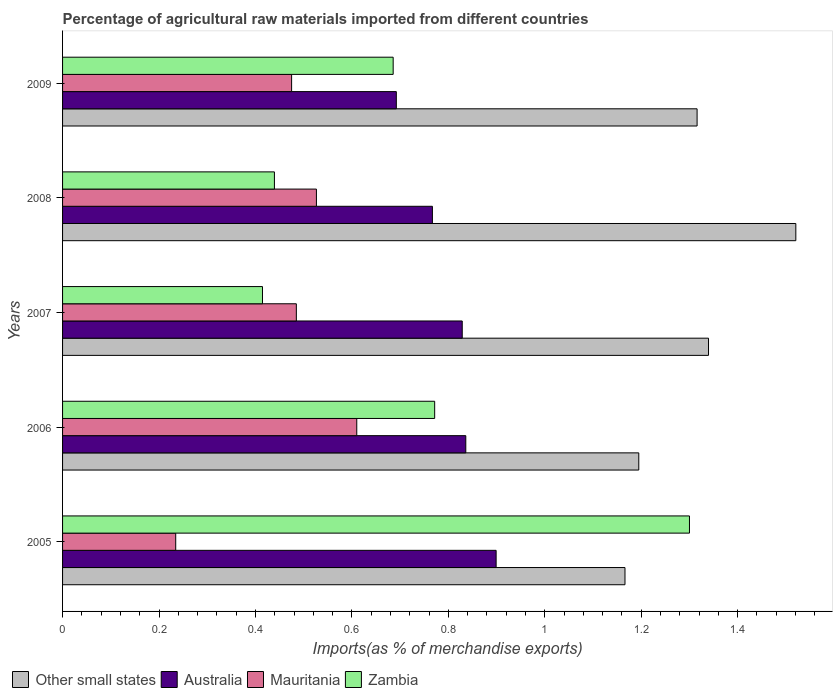How many bars are there on the 2nd tick from the bottom?
Give a very brief answer. 4. What is the label of the 3rd group of bars from the top?
Offer a very short reply. 2007. What is the percentage of imports to different countries in Mauritania in 2007?
Make the answer very short. 0.48. Across all years, what is the maximum percentage of imports to different countries in Zambia?
Your answer should be very brief. 1.3. Across all years, what is the minimum percentage of imports to different countries in Other small states?
Offer a terse response. 1.17. In which year was the percentage of imports to different countries in Other small states maximum?
Offer a very short reply. 2008. In which year was the percentage of imports to different countries in Mauritania minimum?
Keep it short and to the point. 2005. What is the total percentage of imports to different countries in Zambia in the graph?
Your response must be concise. 3.61. What is the difference between the percentage of imports to different countries in Other small states in 2005 and that in 2008?
Provide a short and direct response. -0.35. What is the difference between the percentage of imports to different countries in Australia in 2009 and the percentage of imports to different countries in Other small states in 2008?
Make the answer very short. -0.83. What is the average percentage of imports to different countries in Zambia per year?
Keep it short and to the point. 0.72. In the year 2009, what is the difference between the percentage of imports to different countries in Zambia and percentage of imports to different countries in Other small states?
Provide a succinct answer. -0.63. What is the ratio of the percentage of imports to different countries in Other small states in 2005 to that in 2009?
Your response must be concise. 0.89. What is the difference between the highest and the second highest percentage of imports to different countries in Mauritania?
Offer a terse response. 0.08. What is the difference between the highest and the lowest percentage of imports to different countries in Mauritania?
Keep it short and to the point. 0.38. In how many years, is the percentage of imports to different countries in Other small states greater than the average percentage of imports to different countries in Other small states taken over all years?
Give a very brief answer. 3. What does the 4th bar from the top in 2008 represents?
Your answer should be very brief. Other small states. Is it the case that in every year, the sum of the percentage of imports to different countries in Zambia and percentage of imports to different countries in Australia is greater than the percentage of imports to different countries in Mauritania?
Your answer should be very brief. Yes. How many bars are there?
Keep it short and to the point. 20. Are all the bars in the graph horizontal?
Provide a succinct answer. Yes. How many years are there in the graph?
Make the answer very short. 5. Are the values on the major ticks of X-axis written in scientific E-notation?
Offer a terse response. No. Does the graph contain any zero values?
Keep it short and to the point. No. Does the graph contain grids?
Give a very brief answer. No. What is the title of the graph?
Offer a very short reply. Percentage of agricultural raw materials imported from different countries. What is the label or title of the X-axis?
Make the answer very short. Imports(as % of merchandise exports). What is the label or title of the Y-axis?
Offer a very short reply. Years. What is the Imports(as % of merchandise exports) of Other small states in 2005?
Provide a succinct answer. 1.17. What is the Imports(as % of merchandise exports) of Australia in 2005?
Provide a succinct answer. 0.9. What is the Imports(as % of merchandise exports) of Mauritania in 2005?
Ensure brevity in your answer.  0.23. What is the Imports(as % of merchandise exports) of Zambia in 2005?
Offer a very short reply. 1.3. What is the Imports(as % of merchandise exports) in Other small states in 2006?
Make the answer very short. 1.2. What is the Imports(as % of merchandise exports) in Australia in 2006?
Give a very brief answer. 0.84. What is the Imports(as % of merchandise exports) in Mauritania in 2006?
Keep it short and to the point. 0.61. What is the Imports(as % of merchandise exports) of Zambia in 2006?
Your answer should be compact. 0.77. What is the Imports(as % of merchandise exports) in Other small states in 2007?
Give a very brief answer. 1.34. What is the Imports(as % of merchandise exports) of Australia in 2007?
Provide a short and direct response. 0.83. What is the Imports(as % of merchandise exports) of Mauritania in 2007?
Your response must be concise. 0.48. What is the Imports(as % of merchandise exports) in Zambia in 2007?
Provide a short and direct response. 0.41. What is the Imports(as % of merchandise exports) in Other small states in 2008?
Make the answer very short. 1.52. What is the Imports(as % of merchandise exports) in Australia in 2008?
Give a very brief answer. 0.77. What is the Imports(as % of merchandise exports) of Mauritania in 2008?
Give a very brief answer. 0.53. What is the Imports(as % of merchandise exports) in Zambia in 2008?
Provide a short and direct response. 0.44. What is the Imports(as % of merchandise exports) in Other small states in 2009?
Your answer should be compact. 1.32. What is the Imports(as % of merchandise exports) of Australia in 2009?
Ensure brevity in your answer.  0.69. What is the Imports(as % of merchandise exports) in Mauritania in 2009?
Provide a succinct answer. 0.48. What is the Imports(as % of merchandise exports) in Zambia in 2009?
Keep it short and to the point. 0.69. Across all years, what is the maximum Imports(as % of merchandise exports) in Other small states?
Your response must be concise. 1.52. Across all years, what is the maximum Imports(as % of merchandise exports) in Australia?
Your answer should be very brief. 0.9. Across all years, what is the maximum Imports(as % of merchandise exports) of Mauritania?
Your response must be concise. 0.61. Across all years, what is the maximum Imports(as % of merchandise exports) of Zambia?
Give a very brief answer. 1.3. Across all years, what is the minimum Imports(as % of merchandise exports) in Other small states?
Offer a terse response. 1.17. Across all years, what is the minimum Imports(as % of merchandise exports) in Australia?
Provide a succinct answer. 0.69. Across all years, what is the minimum Imports(as % of merchandise exports) in Mauritania?
Give a very brief answer. 0.23. Across all years, what is the minimum Imports(as % of merchandise exports) in Zambia?
Provide a short and direct response. 0.41. What is the total Imports(as % of merchandise exports) in Other small states in the graph?
Offer a very short reply. 6.54. What is the total Imports(as % of merchandise exports) of Australia in the graph?
Make the answer very short. 4.02. What is the total Imports(as % of merchandise exports) in Mauritania in the graph?
Give a very brief answer. 2.33. What is the total Imports(as % of merchandise exports) of Zambia in the graph?
Offer a very short reply. 3.61. What is the difference between the Imports(as % of merchandise exports) of Other small states in 2005 and that in 2006?
Keep it short and to the point. -0.03. What is the difference between the Imports(as % of merchandise exports) in Australia in 2005 and that in 2006?
Provide a short and direct response. 0.06. What is the difference between the Imports(as % of merchandise exports) in Mauritania in 2005 and that in 2006?
Provide a short and direct response. -0.38. What is the difference between the Imports(as % of merchandise exports) in Zambia in 2005 and that in 2006?
Provide a short and direct response. 0.53. What is the difference between the Imports(as % of merchandise exports) in Other small states in 2005 and that in 2007?
Provide a short and direct response. -0.17. What is the difference between the Imports(as % of merchandise exports) of Australia in 2005 and that in 2007?
Ensure brevity in your answer.  0.07. What is the difference between the Imports(as % of merchandise exports) of Mauritania in 2005 and that in 2007?
Keep it short and to the point. -0.25. What is the difference between the Imports(as % of merchandise exports) of Zambia in 2005 and that in 2007?
Your answer should be very brief. 0.89. What is the difference between the Imports(as % of merchandise exports) in Other small states in 2005 and that in 2008?
Make the answer very short. -0.35. What is the difference between the Imports(as % of merchandise exports) of Australia in 2005 and that in 2008?
Give a very brief answer. 0.13. What is the difference between the Imports(as % of merchandise exports) in Mauritania in 2005 and that in 2008?
Offer a very short reply. -0.29. What is the difference between the Imports(as % of merchandise exports) of Zambia in 2005 and that in 2008?
Offer a very short reply. 0.86. What is the difference between the Imports(as % of merchandise exports) in Other small states in 2005 and that in 2009?
Keep it short and to the point. -0.15. What is the difference between the Imports(as % of merchandise exports) in Australia in 2005 and that in 2009?
Your response must be concise. 0.21. What is the difference between the Imports(as % of merchandise exports) in Mauritania in 2005 and that in 2009?
Your response must be concise. -0.24. What is the difference between the Imports(as % of merchandise exports) in Zambia in 2005 and that in 2009?
Offer a terse response. 0.61. What is the difference between the Imports(as % of merchandise exports) in Other small states in 2006 and that in 2007?
Your answer should be compact. -0.14. What is the difference between the Imports(as % of merchandise exports) of Australia in 2006 and that in 2007?
Your response must be concise. 0.01. What is the difference between the Imports(as % of merchandise exports) of Mauritania in 2006 and that in 2007?
Offer a terse response. 0.13. What is the difference between the Imports(as % of merchandise exports) in Zambia in 2006 and that in 2007?
Ensure brevity in your answer.  0.36. What is the difference between the Imports(as % of merchandise exports) in Other small states in 2006 and that in 2008?
Give a very brief answer. -0.33. What is the difference between the Imports(as % of merchandise exports) in Australia in 2006 and that in 2008?
Keep it short and to the point. 0.07. What is the difference between the Imports(as % of merchandise exports) in Mauritania in 2006 and that in 2008?
Provide a short and direct response. 0.08. What is the difference between the Imports(as % of merchandise exports) of Zambia in 2006 and that in 2008?
Provide a short and direct response. 0.33. What is the difference between the Imports(as % of merchandise exports) in Other small states in 2006 and that in 2009?
Your answer should be very brief. -0.12. What is the difference between the Imports(as % of merchandise exports) in Australia in 2006 and that in 2009?
Keep it short and to the point. 0.14. What is the difference between the Imports(as % of merchandise exports) in Mauritania in 2006 and that in 2009?
Offer a terse response. 0.14. What is the difference between the Imports(as % of merchandise exports) in Zambia in 2006 and that in 2009?
Ensure brevity in your answer.  0.09. What is the difference between the Imports(as % of merchandise exports) of Other small states in 2007 and that in 2008?
Your response must be concise. -0.18. What is the difference between the Imports(as % of merchandise exports) of Australia in 2007 and that in 2008?
Keep it short and to the point. 0.06. What is the difference between the Imports(as % of merchandise exports) in Mauritania in 2007 and that in 2008?
Your response must be concise. -0.04. What is the difference between the Imports(as % of merchandise exports) of Zambia in 2007 and that in 2008?
Offer a terse response. -0.02. What is the difference between the Imports(as % of merchandise exports) of Other small states in 2007 and that in 2009?
Provide a succinct answer. 0.02. What is the difference between the Imports(as % of merchandise exports) in Australia in 2007 and that in 2009?
Ensure brevity in your answer.  0.14. What is the difference between the Imports(as % of merchandise exports) of Mauritania in 2007 and that in 2009?
Your response must be concise. 0.01. What is the difference between the Imports(as % of merchandise exports) in Zambia in 2007 and that in 2009?
Your response must be concise. -0.27. What is the difference between the Imports(as % of merchandise exports) in Other small states in 2008 and that in 2009?
Ensure brevity in your answer.  0.2. What is the difference between the Imports(as % of merchandise exports) of Australia in 2008 and that in 2009?
Offer a terse response. 0.07. What is the difference between the Imports(as % of merchandise exports) in Mauritania in 2008 and that in 2009?
Offer a very short reply. 0.05. What is the difference between the Imports(as % of merchandise exports) in Zambia in 2008 and that in 2009?
Offer a terse response. -0.25. What is the difference between the Imports(as % of merchandise exports) in Other small states in 2005 and the Imports(as % of merchandise exports) in Australia in 2006?
Your response must be concise. 0.33. What is the difference between the Imports(as % of merchandise exports) of Other small states in 2005 and the Imports(as % of merchandise exports) of Mauritania in 2006?
Offer a terse response. 0.56. What is the difference between the Imports(as % of merchandise exports) of Other small states in 2005 and the Imports(as % of merchandise exports) of Zambia in 2006?
Your answer should be compact. 0.39. What is the difference between the Imports(as % of merchandise exports) of Australia in 2005 and the Imports(as % of merchandise exports) of Mauritania in 2006?
Provide a succinct answer. 0.29. What is the difference between the Imports(as % of merchandise exports) of Australia in 2005 and the Imports(as % of merchandise exports) of Zambia in 2006?
Your answer should be compact. 0.13. What is the difference between the Imports(as % of merchandise exports) of Mauritania in 2005 and the Imports(as % of merchandise exports) of Zambia in 2006?
Provide a short and direct response. -0.54. What is the difference between the Imports(as % of merchandise exports) in Other small states in 2005 and the Imports(as % of merchandise exports) in Australia in 2007?
Offer a terse response. 0.34. What is the difference between the Imports(as % of merchandise exports) in Other small states in 2005 and the Imports(as % of merchandise exports) in Mauritania in 2007?
Keep it short and to the point. 0.68. What is the difference between the Imports(as % of merchandise exports) in Other small states in 2005 and the Imports(as % of merchandise exports) in Zambia in 2007?
Your answer should be compact. 0.75. What is the difference between the Imports(as % of merchandise exports) in Australia in 2005 and the Imports(as % of merchandise exports) in Mauritania in 2007?
Your answer should be very brief. 0.41. What is the difference between the Imports(as % of merchandise exports) in Australia in 2005 and the Imports(as % of merchandise exports) in Zambia in 2007?
Keep it short and to the point. 0.48. What is the difference between the Imports(as % of merchandise exports) in Mauritania in 2005 and the Imports(as % of merchandise exports) in Zambia in 2007?
Your answer should be very brief. -0.18. What is the difference between the Imports(as % of merchandise exports) of Other small states in 2005 and the Imports(as % of merchandise exports) of Australia in 2008?
Your answer should be very brief. 0.4. What is the difference between the Imports(as % of merchandise exports) of Other small states in 2005 and the Imports(as % of merchandise exports) of Mauritania in 2008?
Keep it short and to the point. 0.64. What is the difference between the Imports(as % of merchandise exports) of Other small states in 2005 and the Imports(as % of merchandise exports) of Zambia in 2008?
Offer a terse response. 0.73. What is the difference between the Imports(as % of merchandise exports) of Australia in 2005 and the Imports(as % of merchandise exports) of Mauritania in 2008?
Your answer should be compact. 0.37. What is the difference between the Imports(as % of merchandise exports) in Australia in 2005 and the Imports(as % of merchandise exports) in Zambia in 2008?
Your response must be concise. 0.46. What is the difference between the Imports(as % of merchandise exports) of Mauritania in 2005 and the Imports(as % of merchandise exports) of Zambia in 2008?
Provide a succinct answer. -0.2. What is the difference between the Imports(as % of merchandise exports) in Other small states in 2005 and the Imports(as % of merchandise exports) in Australia in 2009?
Your response must be concise. 0.47. What is the difference between the Imports(as % of merchandise exports) in Other small states in 2005 and the Imports(as % of merchandise exports) in Mauritania in 2009?
Provide a succinct answer. 0.69. What is the difference between the Imports(as % of merchandise exports) in Other small states in 2005 and the Imports(as % of merchandise exports) in Zambia in 2009?
Give a very brief answer. 0.48. What is the difference between the Imports(as % of merchandise exports) of Australia in 2005 and the Imports(as % of merchandise exports) of Mauritania in 2009?
Offer a terse response. 0.42. What is the difference between the Imports(as % of merchandise exports) in Australia in 2005 and the Imports(as % of merchandise exports) in Zambia in 2009?
Provide a succinct answer. 0.21. What is the difference between the Imports(as % of merchandise exports) of Mauritania in 2005 and the Imports(as % of merchandise exports) of Zambia in 2009?
Your answer should be very brief. -0.45. What is the difference between the Imports(as % of merchandise exports) of Other small states in 2006 and the Imports(as % of merchandise exports) of Australia in 2007?
Your answer should be compact. 0.37. What is the difference between the Imports(as % of merchandise exports) of Other small states in 2006 and the Imports(as % of merchandise exports) of Mauritania in 2007?
Your answer should be very brief. 0.71. What is the difference between the Imports(as % of merchandise exports) of Other small states in 2006 and the Imports(as % of merchandise exports) of Zambia in 2007?
Your answer should be very brief. 0.78. What is the difference between the Imports(as % of merchandise exports) of Australia in 2006 and the Imports(as % of merchandise exports) of Mauritania in 2007?
Provide a succinct answer. 0.35. What is the difference between the Imports(as % of merchandise exports) of Australia in 2006 and the Imports(as % of merchandise exports) of Zambia in 2007?
Provide a succinct answer. 0.42. What is the difference between the Imports(as % of merchandise exports) in Mauritania in 2006 and the Imports(as % of merchandise exports) in Zambia in 2007?
Your response must be concise. 0.2. What is the difference between the Imports(as % of merchandise exports) in Other small states in 2006 and the Imports(as % of merchandise exports) in Australia in 2008?
Give a very brief answer. 0.43. What is the difference between the Imports(as % of merchandise exports) of Other small states in 2006 and the Imports(as % of merchandise exports) of Mauritania in 2008?
Your answer should be compact. 0.67. What is the difference between the Imports(as % of merchandise exports) of Other small states in 2006 and the Imports(as % of merchandise exports) of Zambia in 2008?
Provide a succinct answer. 0.76. What is the difference between the Imports(as % of merchandise exports) in Australia in 2006 and the Imports(as % of merchandise exports) in Mauritania in 2008?
Your answer should be compact. 0.31. What is the difference between the Imports(as % of merchandise exports) of Australia in 2006 and the Imports(as % of merchandise exports) of Zambia in 2008?
Offer a very short reply. 0.4. What is the difference between the Imports(as % of merchandise exports) in Mauritania in 2006 and the Imports(as % of merchandise exports) in Zambia in 2008?
Keep it short and to the point. 0.17. What is the difference between the Imports(as % of merchandise exports) in Other small states in 2006 and the Imports(as % of merchandise exports) in Australia in 2009?
Your response must be concise. 0.5. What is the difference between the Imports(as % of merchandise exports) in Other small states in 2006 and the Imports(as % of merchandise exports) in Mauritania in 2009?
Give a very brief answer. 0.72. What is the difference between the Imports(as % of merchandise exports) of Other small states in 2006 and the Imports(as % of merchandise exports) of Zambia in 2009?
Your answer should be very brief. 0.51. What is the difference between the Imports(as % of merchandise exports) of Australia in 2006 and the Imports(as % of merchandise exports) of Mauritania in 2009?
Offer a very short reply. 0.36. What is the difference between the Imports(as % of merchandise exports) of Australia in 2006 and the Imports(as % of merchandise exports) of Zambia in 2009?
Offer a terse response. 0.15. What is the difference between the Imports(as % of merchandise exports) in Mauritania in 2006 and the Imports(as % of merchandise exports) in Zambia in 2009?
Offer a terse response. -0.08. What is the difference between the Imports(as % of merchandise exports) of Other small states in 2007 and the Imports(as % of merchandise exports) of Australia in 2008?
Your response must be concise. 0.57. What is the difference between the Imports(as % of merchandise exports) in Other small states in 2007 and the Imports(as % of merchandise exports) in Mauritania in 2008?
Your answer should be very brief. 0.81. What is the difference between the Imports(as % of merchandise exports) in Other small states in 2007 and the Imports(as % of merchandise exports) in Zambia in 2008?
Your response must be concise. 0.9. What is the difference between the Imports(as % of merchandise exports) of Australia in 2007 and the Imports(as % of merchandise exports) of Mauritania in 2008?
Give a very brief answer. 0.3. What is the difference between the Imports(as % of merchandise exports) of Australia in 2007 and the Imports(as % of merchandise exports) of Zambia in 2008?
Provide a succinct answer. 0.39. What is the difference between the Imports(as % of merchandise exports) in Mauritania in 2007 and the Imports(as % of merchandise exports) in Zambia in 2008?
Provide a short and direct response. 0.05. What is the difference between the Imports(as % of merchandise exports) of Other small states in 2007 and the Imports(as % of merchandise exports) of Australia in 2009?
Give a very brief answer. 0.65. What is the difference between the Imports(as % of merchandise exports) in Other small states in 2007 and the Imports(as % of merchandise exports) in Mauritania in 2009?
Give a very brief answer. 0.86. What is the difference between the Imports(as % of merchandise exports) in Other small states in 2007 and the Imports(as % of merchandise exports) in Zambia in 2009?
Offer a very short reply. 0.65. What is the difference between the Imports(as % of merchandise exports) of Australia in 2007 and the Imports(as % of merchandise exports) of Mauritania in 2009?
Provide a succinct answer. 0.35. What is the difference between the Imports(as % of merchandise exports) of Australia in 2007 and the Imports(as % of merchandise exports) of Zambia in 2009?
Your response must be concise. 0.14. What is the difference between the Imports(as % of merchandise exports) of Mauritania in 2007 and the Imports(as % of merchandise exports) of Zambia in 2009?
Your response must be concise. -0.2. What is the difference between the Imports(as % of merchandise exports) in Other small states in 2008 and the Imports(as % of merchandise exports) in Australia in 2009?
Keep it short and to the point. 0.83. What is the difference between the Imports(as % of merchandise exports) in Other small states in 2008 and the Imports(as % of merchandise exports) in Mauritania in 2009?
Provide a short and direct response. 1.05. What is the difference between the Imports(as % of merchandise exports) of Other small states in 2008 and the Imports(as % of merchandise exports) of Zambia in 2009?
Ensure brevity in your answer.  0.84. What is the difference between the Imports(as % of merchandise exports) of Australia in 2008 and the Imports(as % of merchandise exports) of Mauritania in 2009?
Your response must be concise. 0.29. What is the difference between the Imports(as % of merchandise exports) of Australia in 2008 and the Imports(as % of merchandise exports) of Zambia in 2009?
Make the answer very short. 0.08. What is the difference between the Imports(as % of merchandise exports) in Mauritania in 2008 and the Imports(as % of merchandise exports) in Zambia in 2009?
Your answer should be very brief. -0.16. What is the average Imports(as % of merchandise exports) in Other small states per year?
Give a very brief answer. 1.31. What is the average Imports(as % of merchandise exports) of Australia per year?
Provide a succinct answer. 0.8. What is the average Imports(as % of merchandise exports) in Mauritania per year?
Make the answer very short. 0.47. What is the average Imports(as % of merchandise exports) in Zambia per year?
Make the answer very short. 0.72. In the year 2005, what is the difference between the Imports(as % of merchandise exports) in Other small states and Imports(as % of merchandise exports) in Australia?
Keep it short and to the point. 0.27. In the year 2005, what is the difference between the Imports(as % of merchandise exports) of Other small states and Imports(as % of merchandise exports) of Mauritania?
Give a very brief answer. 0.93. In the year 2005, what is the difference between the Imports(as % of merchandise exports) of Other small states and Imports(as % of merchandise exports) of Zambia?
Provide a succinct answer. -0.13. In the year 2005, what is the difference between the Imports(as % of merchandise exports) of Australia and Imports(as % of merchandise exports) of Mauritania?
Your response must be concise. 0.66. In the year 2005, what is the difference between the Imports(as % of merchandise exports) of Australia and Imports(as % of merchandise exports) of Zambia?
Your response must be concise. -0.4. In the year 2005, what is the difference between the Imports(as % of merchandise exports) in Mauritania and Imports(as % of merchandise exports) in Zambia?
Your answer should be very brief. -1.07. In the year 2006, what is the difference between the Imports(as % of merchandise exports) of Other small states and Imports(as % of merchandise exports) of Australia?
Provide a succinct answer. 0.36. In the year 2006, what is the difference between the Imports(as % of merchandise exports) in Other small states and Imports(as % of merchandise exports) in Mauritania?
Offer a very short reply. 0.58. In the year 2006, what is the difference between the Imports(as % of merchandise exports) in Other small states and Imports(as % of merchandise exports) in Zambia?
Provide a succinct answer. 0.42. In the year 2006, what is the difference between the Imports(as % of merchandise exports) in Australia and Imports(as % of merchandise exports) in Mauritania?
Make the answer very short. 0.23. In the year 2006, what is the difference between the Imports(as % of merchandise exports) of Australia and Imports(as % of merchandise exports) of Zambia?
Offer a very short reply. 0.06. In the year 2006, what is the difference between the Imports(as % of merchandise exports) in Mauritania and Imports(as % of merchandise exports) in Zambia?
Provide a short and direct response. -0.16. In the year 2007, what is the difference between the Imports(as % of merchandise exports) in Other small states and Imports(as % of merchandise exports) in Australia?
Offer a very short reply. 0.51. In the year 2007, what is the difference between the Imports(as % of merchandise exports) of Other small states and Imports(as % of merchandise exports) of Mauritania?
Give a very brief answer. 0.85. In the year 2007, what is the difference between the Imports(as % of merchandise exports) of Other small states and Imports(as % of merchandise exports) of Zambia?
Give a very brief answer. 0.93. In the year 2007, what is the difference between the Imports(as % of merchandise exports) of Australia and Imports(as % of merchandise exports) of Mauritania?
Make the answer very short. 0.34. In the year 2007, what is the difference between the Imports(as % of merchandise exports) of Australia and Imports(as % of merchandise exports) of Zambia?
Provide a succinct answer. 0.41. In the year 2007, what is the difference between the Imports(as % of merchandise exports) of Mauritania and Imports(as % of merchandise exports) of Zambia?
Ensure brevity in your answer.  0.07. In the year 2008, what is the difference between the Imports(as % of merchandise exports) in Other small states and Imports(as % of merchandise exports) in Australia?
Your answer should be compact. 0.75. In the year 2008, what is the difference between the Imports(as % of merchandise exports) in Other small states and Imports(as % of merchandise exports) in Mauritania?
Provide a short and direct response. 0.99. In the year 2008, what is the difference between the Imports(as % of merchandise exports) in Other small states and Imports(as % of merchandise exports) in Zambia?
Your answer should be compact. 1.08. In the year 2008, what is the difference between the Imports(as % of merchandise exports) of Australia and Imports(as % of merchandise exports) of Mauritania?
Offer a very short reply. 0.24. In the year 2008, what is the difference between the Imports(as % of merchandise exports) of Australia and Imports(as % of merchandise exports) of Zambia?
Keep it short and to the point. 0.33. In the year 2008, what is the difference between the Imports(as % of merchandise exports) of Mauritania and Imports(as % of merchandise exports) of Zambia?
Keep it short and to the point. 0.09. In the year 2009, what is the difference between the Imports(as % of merchandise exports) in Other small states and Imports(as % of merchandise exports) in Australia?
Offer a very short reply. 0.62. In the year 2009, what is the difference between the Imports(as % of merchandise exports) of Other small states and Imports(as % of merchandise exports) of Mauritania?
Offer a very short reply. 0.84. In the year 2009, what is the difference between the Imports(as % of merchandise exports) of Other small states and Imports(as % of merchandise exports) of Zambia?
Provide a succinct answer. 0.63. In the year 2009, what is the difference between the Imports(as % of merchandise exports) of Australia and Imports(as % of merchandise exports) of Mauritania?
Ensure brevity in your answer.  0.22. In the year 2009, what is the difference between the Imports(as % of merchandise exports) of Australia and Imports(as % of merchandise exports) of Zambia?
Your answer should be very brief. 0.01. In the year 2009, what is the difference between the Imports(as % of merchandise exports) of Mauritania and Imports(as % of merchandise exports) of Zambia?
Your response must be concise. -0.21. What is the ratio of the Imports(as % of merchandise exports) in Australia in 2005 to that in 2006?
Offer a terse response. 1.08. What is the ratio of the Imports(as % of merchandise exports) in Mauritania in 2005 to that in 2006?
Offer a very short reply. 0.38. What is the ratio of the Imports(as % of merchandise exports) of Zambia in 2005 to that in 2006?
Provide a short and direct response. 1.68. What is the ratio of the Imports(as % of merchandise exports) of Other small states in 2005 to that in 2007?
Provide a short and direct response. 0.87. What is the ratio of the Imports(as % of merchandise exports) in Australia in 2005 to that in 2007?
Give a very brief answer. 1.08. What is the ratio of the Imports(as % of merchandise exports) of Mauritania in 2005 to that in 2007?
Keep it short and to the point. 0.48. What is the ratio of the Imports(as % of merchandise exports) in Zambia in 2005 to that in 2007?
Ensure brevity in your answer.  3.14. What is the ratio of the Imports(as % of merchandise exports) in Other small states in 2005 to that in 2008?
Your response must be concise. 0.77. What is the ratio of the Imports(as % of merchandise exports) of Australia in 2005 to that in 2008?
Ensure brevity in your answer.  1.17. What is the ratio of the Imports(as % of merchandise exports) of Mauritania in 2005 to that in 2008?
Provide a succinct answer. 0.45. What is the ratio of the Imports(as % of merchandise exports) in Zambia in 2005 to that in 2008?
Your answer should be very brief. 2.96. What is the ratio of the Imports(as % of merchandise exports) of Other small states in 2005 to that in 2009?
Make the answer very short. 0.89. What is the ratio of the Imports(as % of merchandise exports) in Australia in 2005 to that in 2009?
Offer a very short reply. 1.3. What is the ratio of the Imports(as % of merchandise exports) of Mauritania in 2005 to that in 2009?
Your answer should be very brief. 0.49. What is the ratio of the Imports(as % of merchandise exports) of Zambia in 2005 to that in 2009?
Offer a very short reply. 1.9. What is the ratio of the Imports(as % of merchandise exports) of Other small states in 2006 to that in 2007?
Keep it short and to the point. 0.89. What is the ratio of the Imports(as % of merchandise exports) in Australia in 2006 to that in 2007?
Your response must be concise. 1.01. What is the ratio of the Imports(as % of merchandise exports) of Mauritania in 2006 to that in 2007?
Ensure brevity in your answer.  1.26. What is the ratio of the Imports(as % of merchandise exports) of Zambia in 2006 to that in 2007?
Your answer should be compact. 1.86. What is the ratio of the Imports(as % of merchandise exports) of Other small states in 2006 to that in 2008?
Make the answer very short. 0.79. What is the ratio of the Imports(as % of merchandise exports) of Australia in 2006 to that in 2008?
Your answer should be compact. 1.09. What is the ratio of the Imports(as % of merchandise exports) of Mauritania in 2006 to that in 2008?
Offer a terse response. 1.16. What is the ratio of the Imports(as % of merchandise exports) in Zambia in 2006 to that in 2008?
Provide a short and direct response. 1.76. What is the ratio of the Imports(as % of merchandise exports) in Other small states in 2006 to that in 2009?
Your response must be concise. 0.91. What is the ratio of the Imports(as % of merchandise exports) of Australia in 2006 to that in 2009?
Provide a short and direct response. 1.21. What is the ratio of the Imports(as % of merchandise exports) of Mauritania in 2006 to that in 2009?
Your answer should be compact. 1.28. What is the ratio of the Imports(as % of merchandise exports) in Zambia in 2006 to that in 2009?
Offer a very short reply. 1.13. What is the ratio of the Imports(as % of merchandise exports) of Other small states in 2007 to that in 2008?
Offer a very short reply. 0.88. What is the ratio of the Imports(as % of merchandise exports) of Australia in 2007 to that in 2008?
Keep it short and to the point. 1.08. What is the ratio of the Imports(as % of merchandise exports) of Mauritania in 2007 to that in 2008?
Your answer should be compact. 0.92. What is the ratio of the Imports(as % of merchandise exports) of Zambia in 2007 to that in 2008?
Keep it short and to the point. 0.94. What is the ratio of the Imports(as % of merchandise exports) of Other small states in 2007 to that in 2009?
Provide a short and direct response. 1.02. What is the ratio of the Imports(as % of merchandise exports) of Australia in 2007 to that in 2009?
Ensure brevity in your answer.  1.2. What is the ratio of the Imports(as % of merchandise exports) of Mauritania in 2007 to that in 2009?
Provide a short and direct response. 1.02. What is the ratio of the Imports(as % of merchandise exports) in Zambia in 2007 to that in 2009?
Provide a succinct answer. 0.6. What is the ratio of the Imports(as % of merchandise exports) in Other small states in 2008 to that in 2009?
Provide a short and direct response. 1.16. What is the ratio of the Imports(as % of merchandise exports) of Australia in 2008 to that in 2009?
Ensure brevity in your answer.  1.11. What is the ratio of the Imports(as % of merchandise exports) of Mauritania in 2008 to that in 2009?
Keep it short and to the point. 1.11. What is the ratio of the Imports(as % of merchandise exports) of Zambia in 2008 to that in 2009?
Give a very brief answer. 0.64. What is the difference between the highest and the second highest Imports(as % of merchandise exports) of Other small states?
Provide a succinct answer. 0.18. What is the difference between the highest and the second highest Imports(as % of merchandise exports) in Australia?
Give a very brief answer. 0.06. What is the difference between the highest and the second highest Imports(as % of merchandise exports) of Mauritania?
Ensure brevity in your answer.  0.08. What is the difference between the highest and the second highest Imports(as % of merchandise exports) of Zambia?
Keep it short and to the point. 0.53. What is the difference between the highest and the lowest Imports(as % of merchandise exports) in Other small states?
Give a very brief answer. 0.35. What is the difference between the highest and the lowest Imports(as % of merchandise exports) of Australia?
Provide a short and direct response. 0.21. What is the difference between the highest and the lowest Imports(as % of merchandise exports) in Mauritania?
Offer a very short reply. 0.38. What is the difference between the highest and the lowest Imports(as % of merchandise exports) of Zambia?
Give a very brief answer. 0.89. 